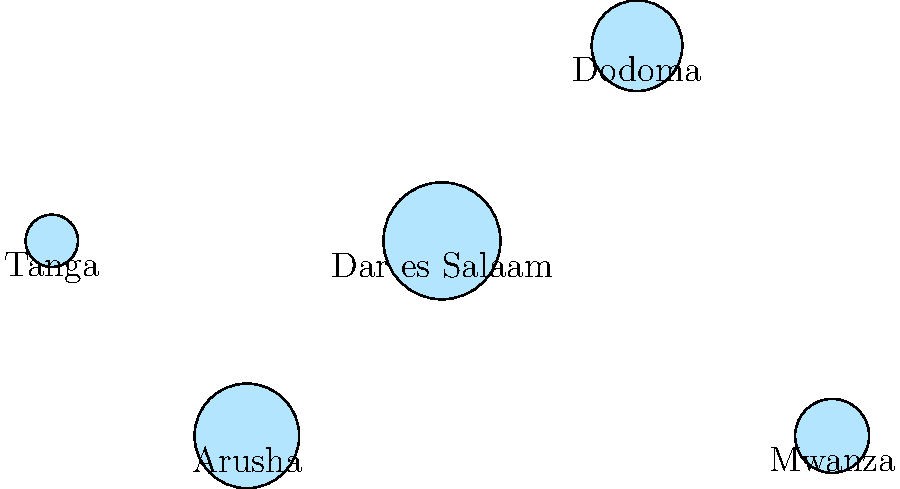Based on the proportional circle map of Tanzanian cities, which city has the highest population density among those represented? To determine the city with the highest population density, we need to analyze the relative sizes of the circles on the map. The area of each circle is proportional to the population of the city it represents. Here's the step-by-step analysis:

1. Observe that the circles represent five major Tanzanian cities: Dar es Salaam, Dodoma, Mwanza, Arusha, and Tanga.

2. Compare the sizes of the circles:
   - Dar es Salaam has the largest circle
   - Arusha has the second-largest circle
   - Dodoma has a medium-sized circle
   - Mwanza has a slightly smaller circle than Dodoma
   - Tanga has the smallest circle

3. The larger the circle, the higher the population of the city.

4. Population density is typically calculated as population divided by area. However, since we don't have information about the area of these cities, we can assume that the population density is roughly proportional to the total population for urban areas.

5. Given this assumption, the city with the largest circle (representing the largest population) is likely to have the highest population density.

Therefore, based on the proportional circle map, Dar es Salaam, represented by the largest circle, is likely to have the highest population density among the cities shown.
Answer: Dar es Salaam 